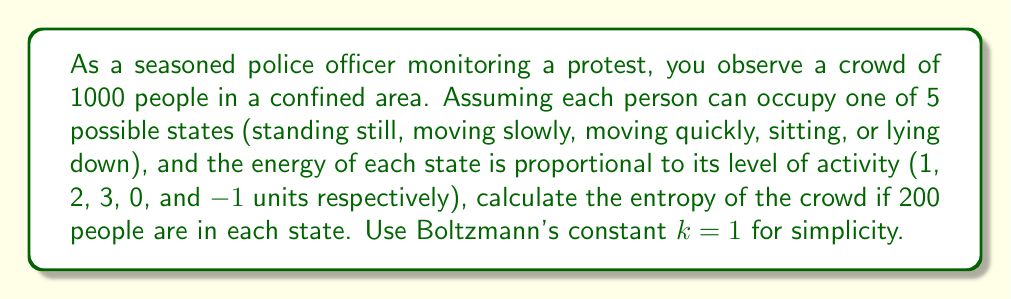Solve this math problem. To determine the entropy of the crowd, we'll use the Boltzmann entropy formula:

$$S = k \ln W$$

where $S$ is entropy, $k$ is Boltzmann's constant (given as 1), and $W$ is the number of microstates.

1) First, calculate $W$ using the multinomial coefficient:

$$W = \frac{N!}{n_1! n_2! n_3! n_4! n_5!}$$

where $N$ is the total number of people and $n_i$ is the number of people in each state.

2) Substitute the values:

$$W = \frac{1000!}{200! 200! 200! 200! 200!}$$

3) Taking the natural logarithm:

$$\ln W = \ln(1000!) - 5\ln(200!)$$

4) Use Stirling's approximation for large $n$: $\ln(n!) \approx n\ln(n) - n$

$$\ln W \approx 1000\ln(1000) - 1000 - 5(200\ln(200) - 200)$$

5) Simplify:

$$\ln W \approx 6907.76 - 1000 - 5(1060.31 - 200)$$
$$\ln W \approx 6907.76 - 1000 - 5301.55 + 1000$$
$$\ln W \approx 1606.21$$

6) Since $k = 1$, the entropy $S$ is equal to $\ln W$:

$$S = 1606.21$$
Answer: $S = 1606.21$ 